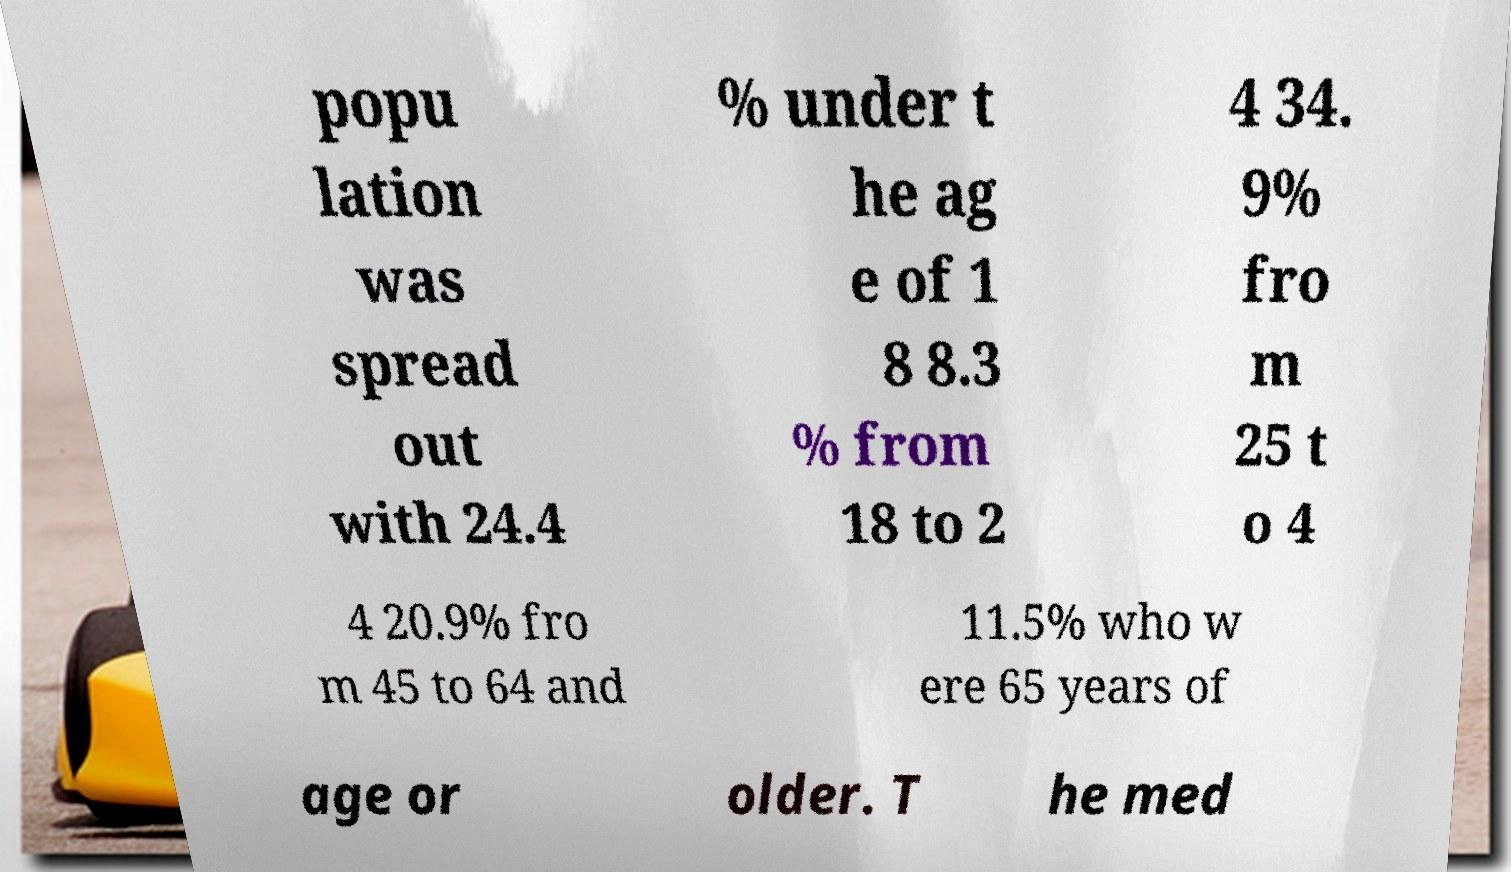Please read and relay the text visible in this image. What does it say? popu lation was spread out with 24.4 % under t he ag e of 1 8 8.3 % from 18 to 2 4 34. 9% fro m 25 t o 4 4 20.9% fro m 45 to 64 and 11.5% who w ere 65 years of age or older. T he med 